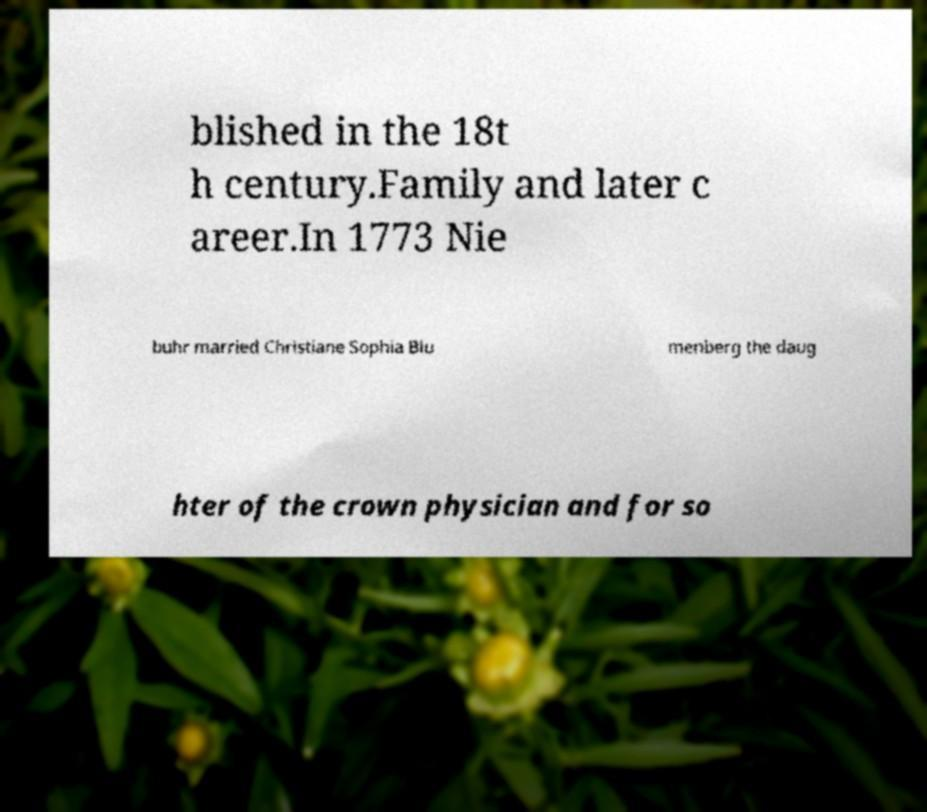What messages or text are displayed in this image? I need them in a readable, typed format. blished in the 18t h century.Family and later c areer.In 1773 Nie buhr married Christiane Sophia Blu menberg the daug hter of the crown physician and for so 